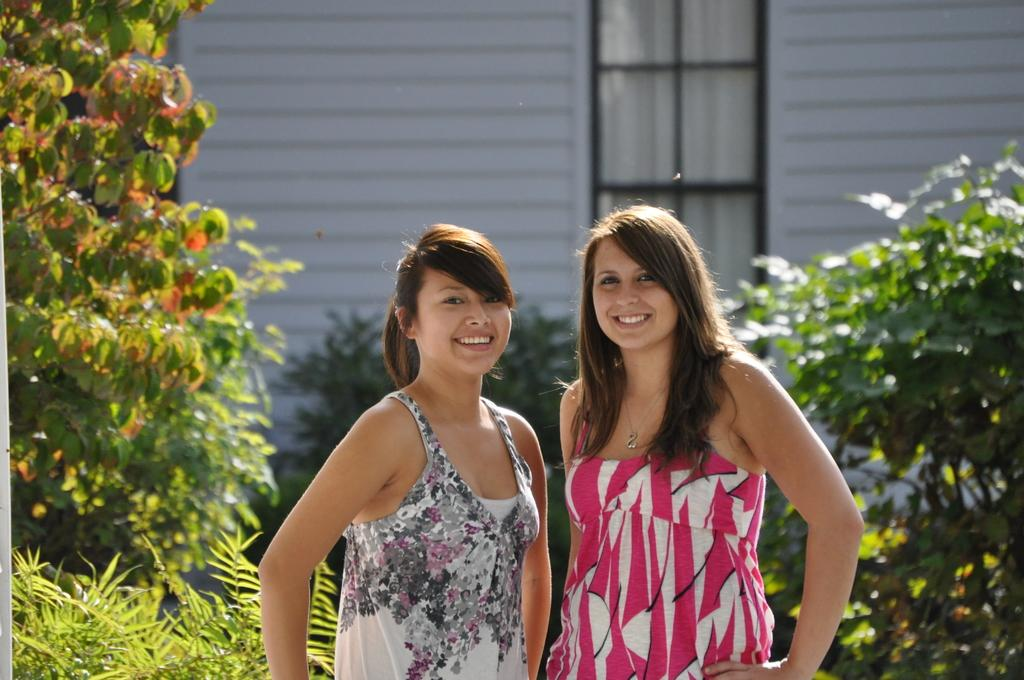How many people are in the image? There are two women in the image. What are the women doing in the image? The women are standing and smiling. What can be seen in the background of the image? There are plants, a wall, and a glass window in the background of the image. What is visible through the glass window? A curtain is visible through the glass window. What type of news can be heard in the background of the image? There is no indication of any news or sound in the image, as it is a still photograph. 